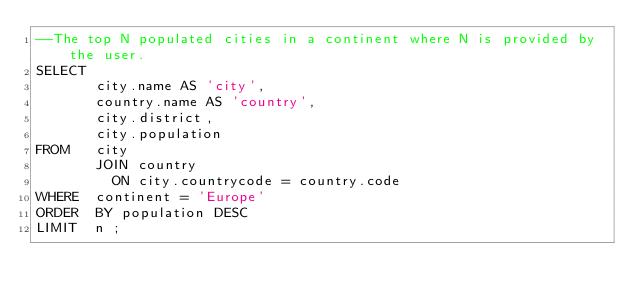<code> <loc_0><loc_0><loc_500><loc_500><_SQL_>--The top N populated cities in a continent where N is provided by the user.
SELECT 
       city.name AS 'city',
       country.name AS 'country',
       city.district,
       city.population
FROM   city
       JOIN country
         ON city.countrycode = country.code
WHERE  continent = 'Europe'
ORDER  BY population DESC
LIMIT  n ;</code> 